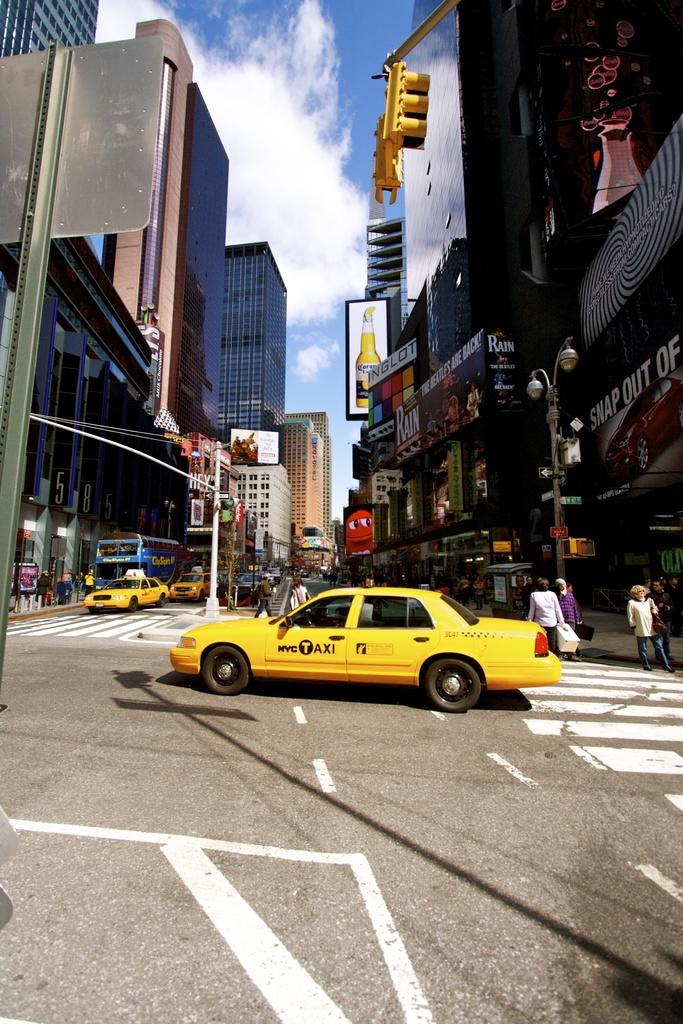<image>
Present a compact description of the photo's key features. A NYC Taxi drives through an intersection in New York City. 